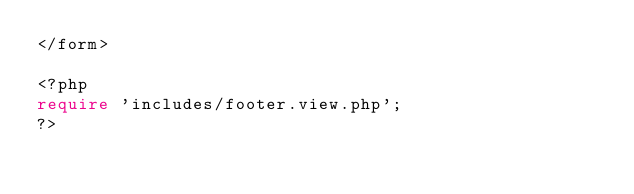<code> <loc_0><loc_0><loc_500><loc_500><_PHP_></form>

<?php
require 'includes/footer.view.php';
?></code> 